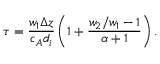<formula> <loc_0><loc_0><loc_500><loc_500>\tau = \frac { w _ { 1 } \Delta z } { c _ { A } d _ { i } } \left ( 1 + \frac { w _ { 2 } / w _ { 1 } - 1 } { \alpha + 1 } \right ) .</formula> 